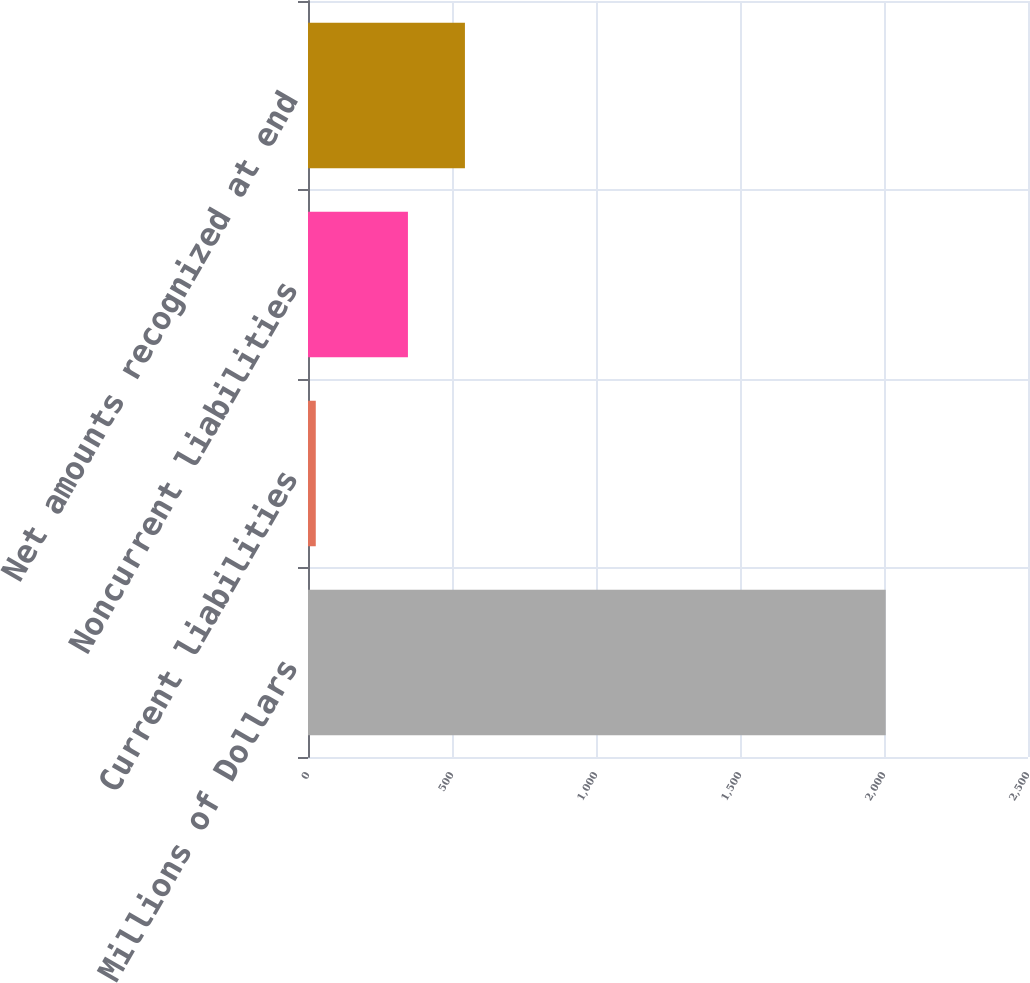Convert chart. <chart><loc_0><loc_0><loc_500><loc_500><bar_chart><fcel>Millions of Dollars<fcel>Current liabilities<fcel>Noncurrent liabilities<fcel>Net amounts recognized at end<nl><fcel>2006<fcel>27<fcel>347<fcel>544.9<nl></chart> 